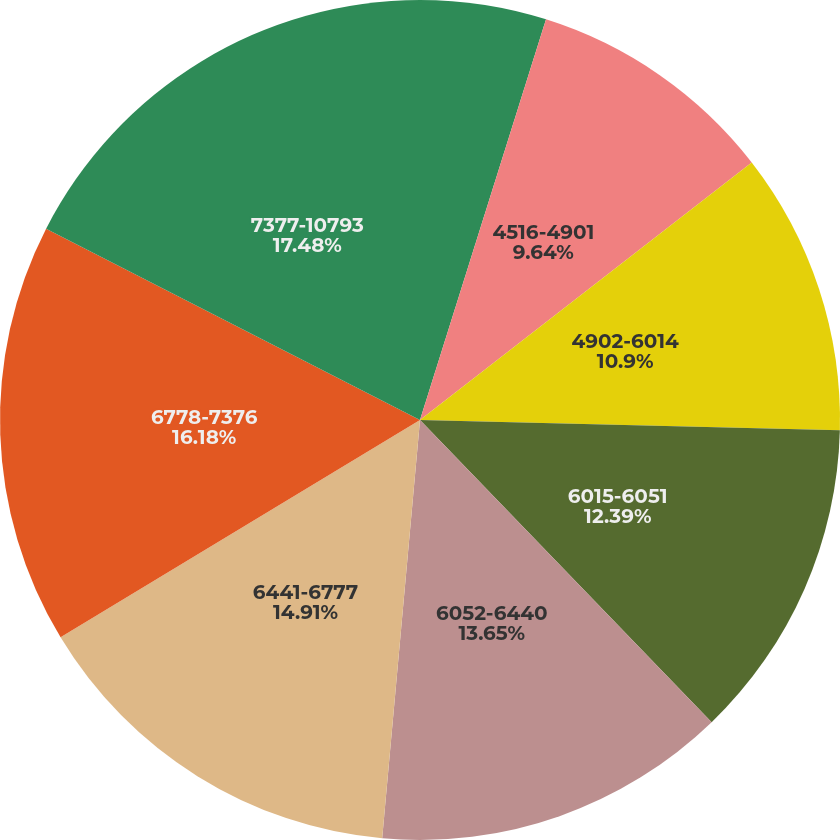Convert chart to OTSL. <chart><loc_0><loc_0><loc_500><loc_500><pie_chart><fcel>1948-4515<fcel>4516-4901<fcel>4902-6014<fcel>6015-6051<fcel>6052-6440<fcel>6441-6777<fcel>6778-7376<fcel>7377-10793<nl><fcel>4.85%<fcel>9.64%<fcel>10.9%<fcel>12.39%<fcel>13.65%<fcel>14.91%<fcel>16.18%<fcel>17.47%<nl></chart> 